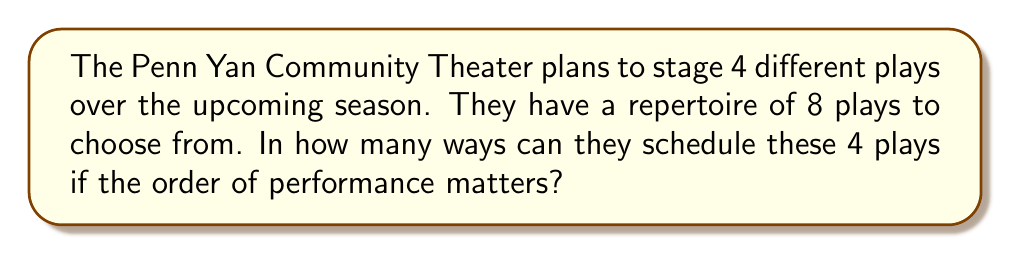Could you help me with this problem? Let's approach this step-by-step:

1) This is a permutation problem because the order matters (the sequence of plays in the season is important).

2) We are selecting 4 plays out of 8, and the order is important.

3) The formula for permutations is:

   $$P(n,r) = \frac{n!}{(n-r)!}$$

   Where $n$ is the total number of items to choose from, and $r$ is the number of items being chosen.

4) In this case, $n = 8$ (total plays) and $r = 4$ (plays to be scheduled).

5) Plugging these values into the formula:

   $$P(8,4) = \frac{8!}{(8-4)!} = \frac{8!}{4!}$$

6) Expanding this:
   
   $$\frac{8 * 7 * 6 * 5 * 4!}{4!}$$

7) The $4!$ cancels out in the numerator and denominator:

   $$8 * 7 * 6 * 5 = 1680$$

Therefore, there are 1680 ways to schedule 4 plays out of 8 for the season.
Answer: 1680 